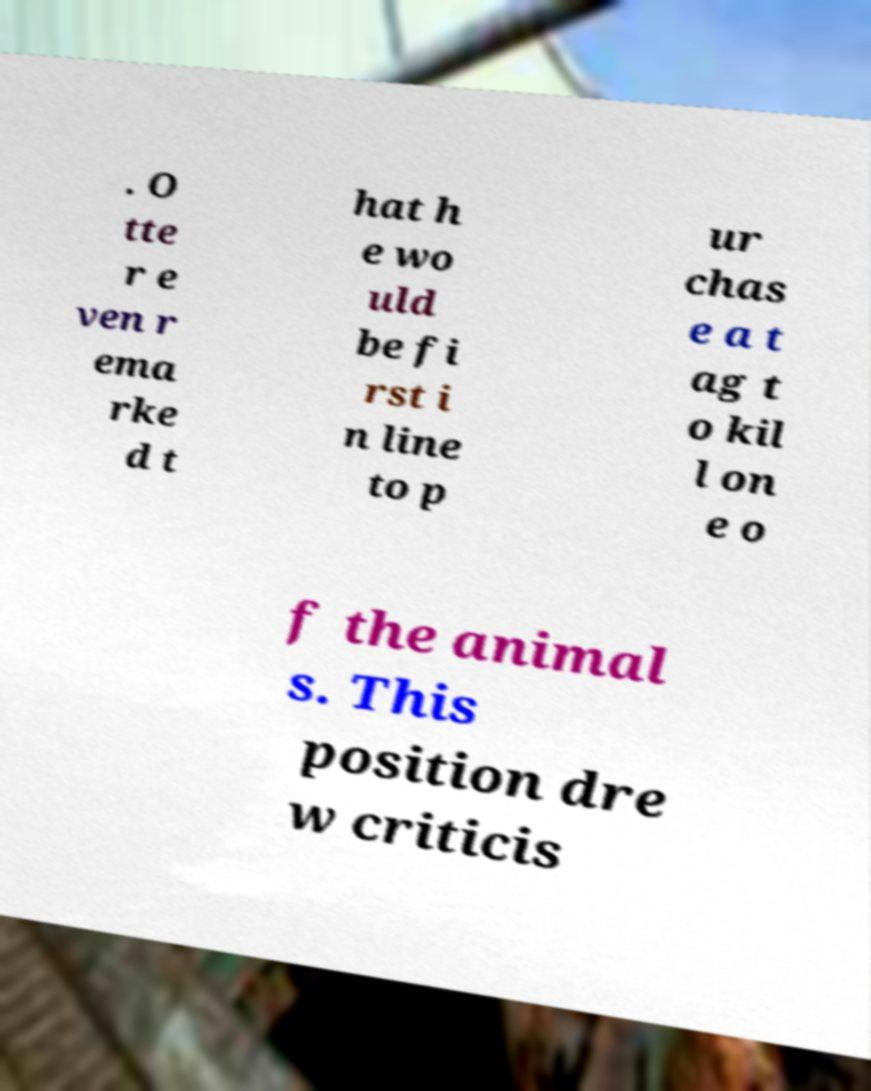What messages or text are displayed in this image? I need them in a readable, typed format. . O tte r e ven r ema rke d t hat h e wo uld be fi rst i n line to p ur chas e a t ag t o kil l on e o f the animal s. This position dre w criticis 